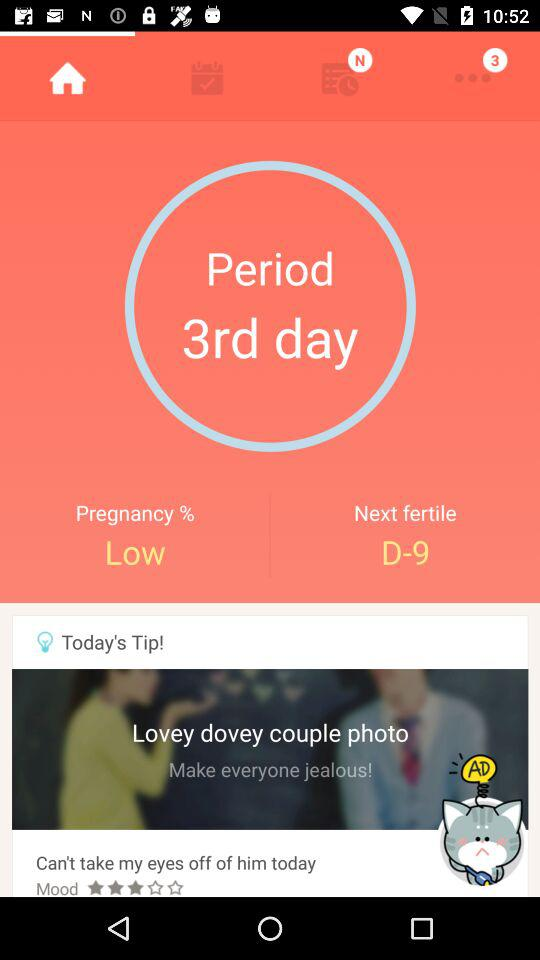Which tab am I on? You are on the "Home" tab. 